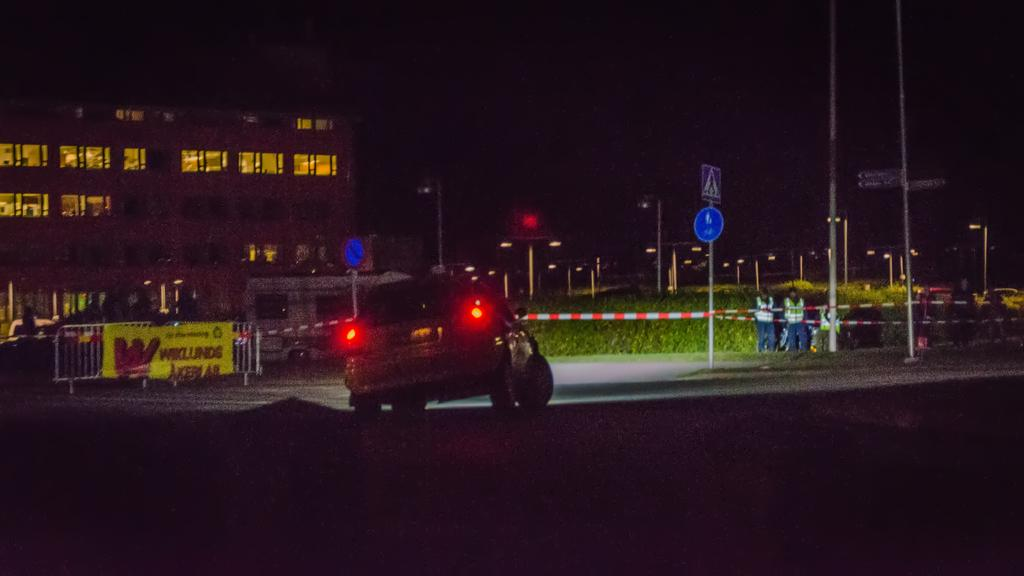How many people are present in the image? There is a group of people in the image, but the exact number cannot be determined from the provided facts. What else can be seen in the image besides the group of people? There are vehicles, poles, sign boards, grass, buildings, and lights visible in the image. What type of structures are visible in the background of the image? There are buildings in the background of the image. What might be used for illumination in the image? Lights are visible in the image. What type of meat is being grilled on the toes of the people in the image? There is no meat or toes present in the image; it features a group of people, vehicles, poles, sign boards, grass, buildings, and lights. 